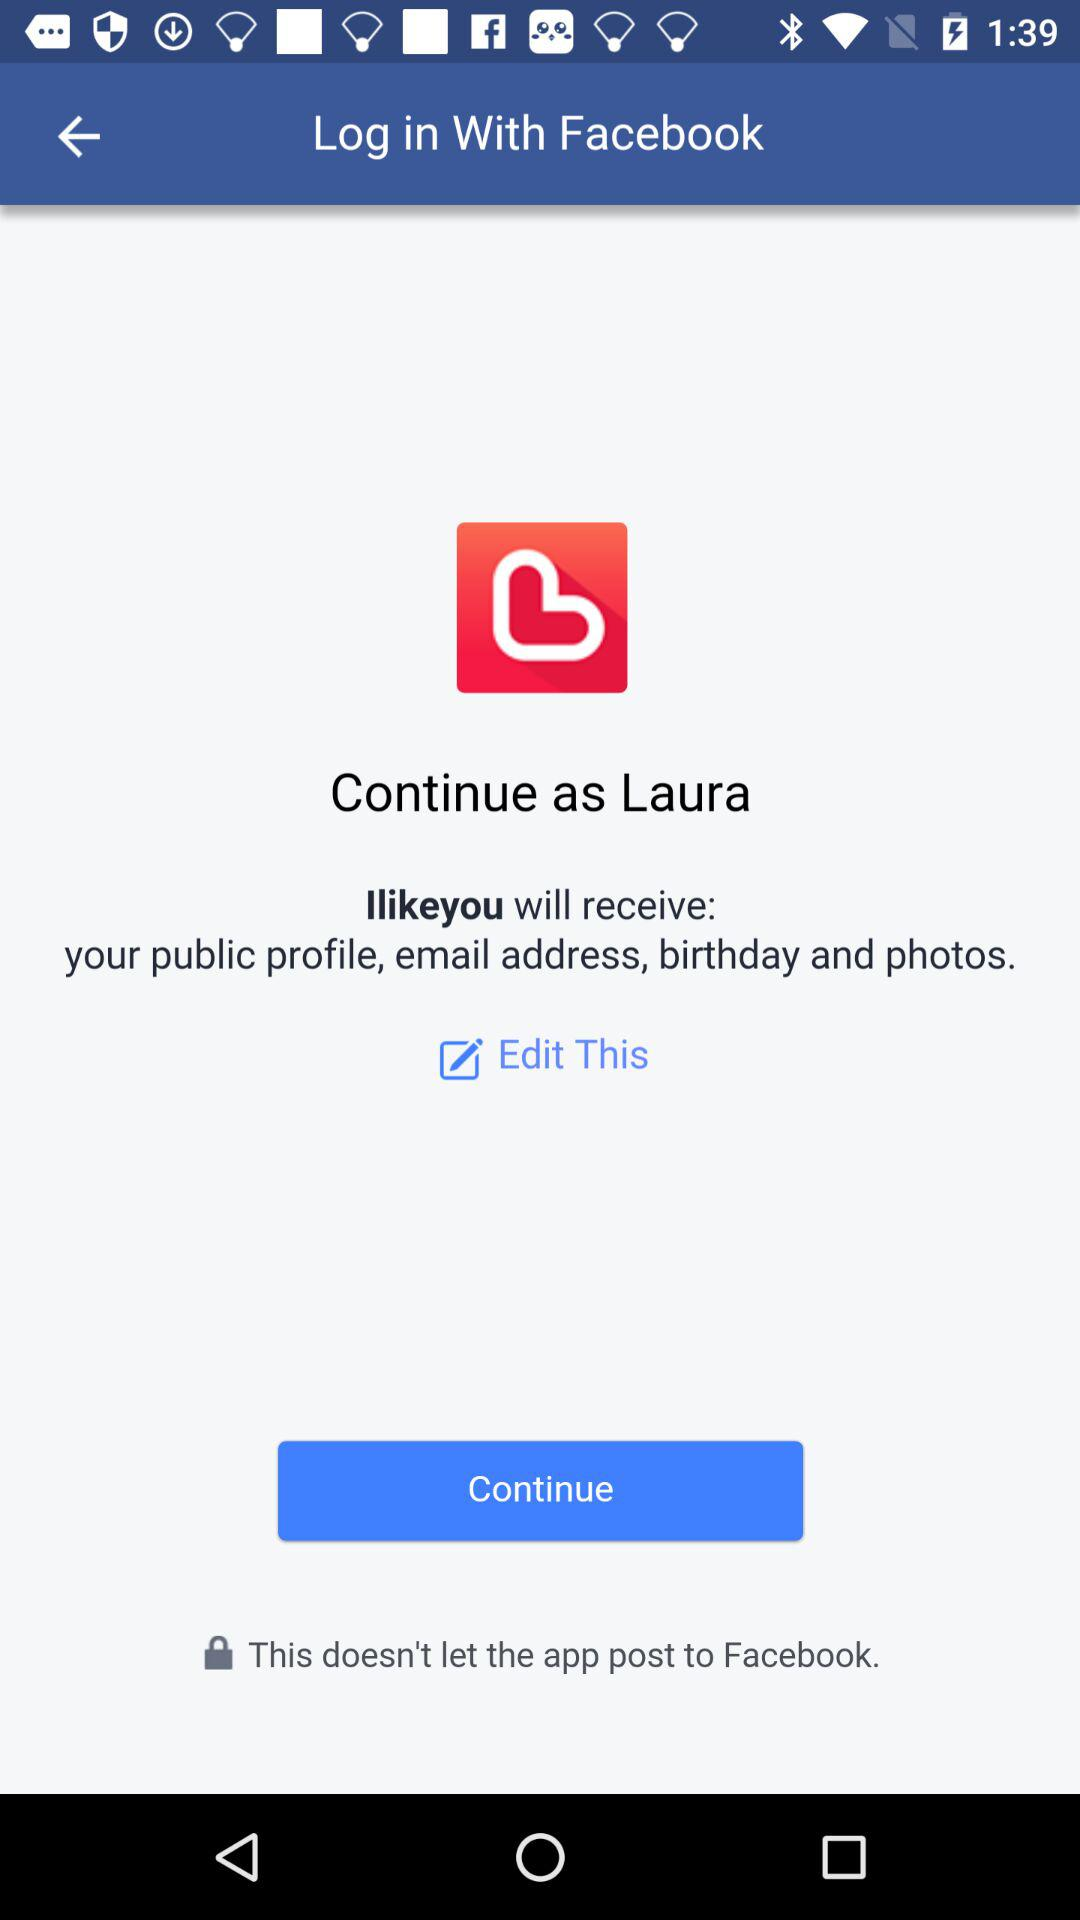What is the given user name? The given user name is Laura. 